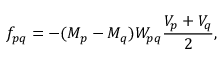<formula> <loc_0><loc_0><loc_500><loc_500>f _ { p q } = - ( M _ { p } - M _ { q } ) W _ { p q } \frac { V _ { p } + V _ { q } } { 2 } ,</formula> 